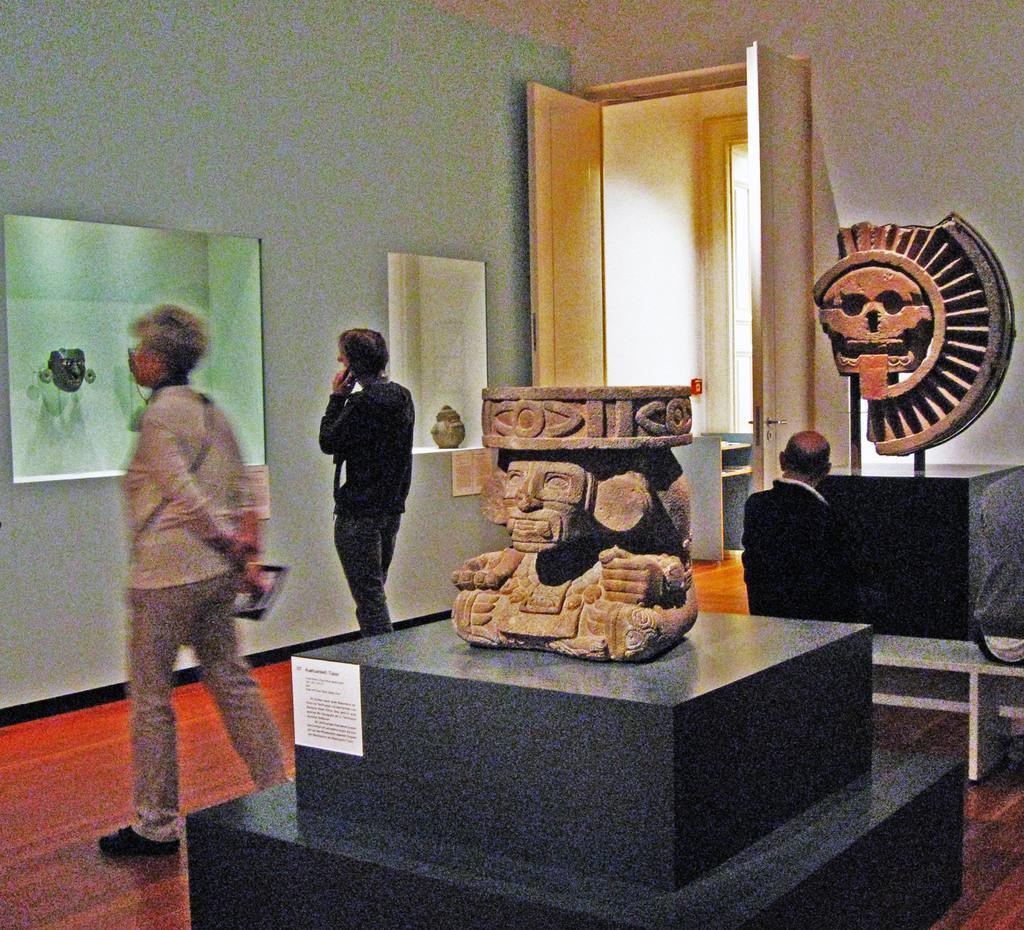In one or two sentences, can you explain what this image depicts? Here in this picture we can see some old stones, that are crafted present over a place and we can also see people standing on the floor and watching items present in the racks and we can also see doors present in the middle. 